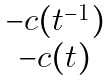Convert formula to latex. <formula><loc_0><loc_0><loc_500><loc_500>\begin{matrix} - c ( t ^ { - 1 } ) \\ - c ( t ) \end{matrix}</formula> 